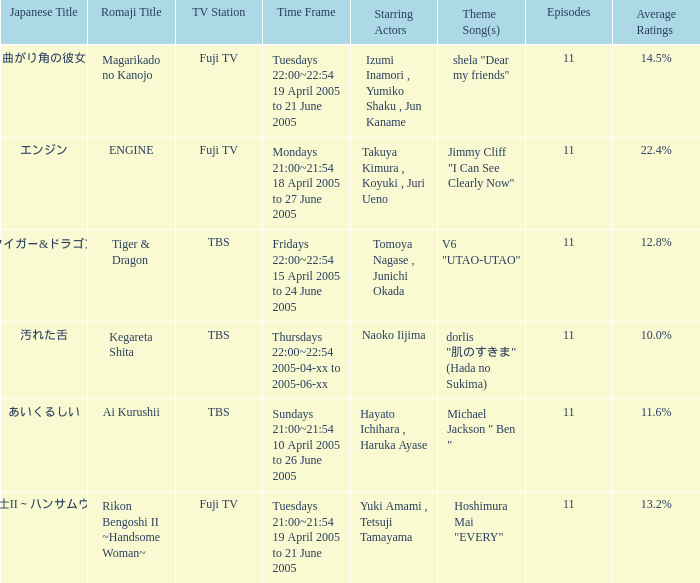What is maximum number of episodes for a show? 11.0. 